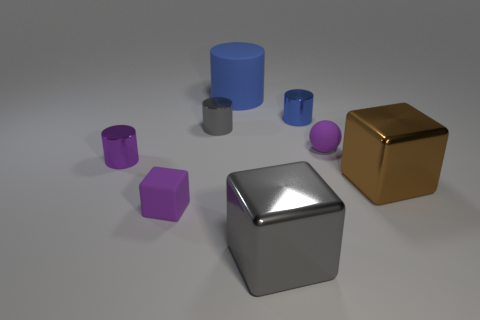Subtract all small gray shiny cylinders. How many cylinders are left? 3 Subtract all blue cylinders. How many cylinders are left? 2 Subtract all yellow spheres. How many gray cylinders are left? 1 Subtract all spheres. How many objects are left? 7 Subtract 3 blocks. How many blocks are left? 0 Subtract all purple blocks. Subtract all brown balls. How many blocks are left? 2 Subtract all tiny blue metallic cylinders. Subtract all big objects. How many objects are left? 4 Add 5 big blue rubber cylinders. How many big blue rubber cylinders are left? 6 Add 6 large brown matte cylinders. How many large brown matte cylinders exist? 6 Add 2 matte blocks. How many objects exist? 10 